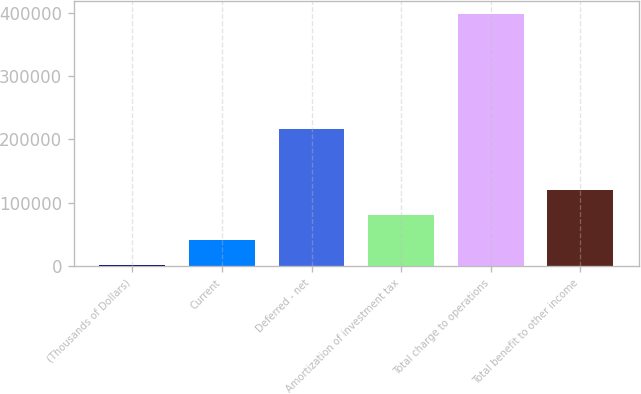<chart> <loc_0><loc_0><loc_500><loc_500><bar_chart><fcel>(Thousands of Dollars)<fcel>Current<fcel>Deferred - net<fcel>Amortization of investment tax<fcel>Total charge to operations<fcel>Total benefit to other income<nl><fcel>2002<fcel>41609<fcel>217192<fcel>81216<fcel>398072<fcel>120823<nl></chart> 